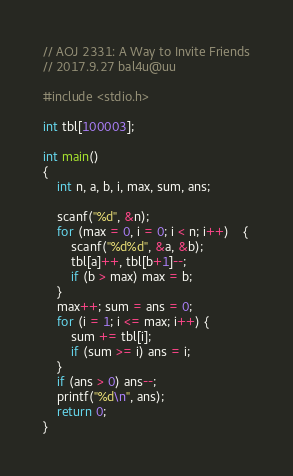Convert code to text. <code><loc_0><loc_0><loc_500><loc_500><_C_>// AOJ 2331: A Way to Invite Friends
// 2017.9.27 bal4u@uu

#include <stdio.h>

int tbl[100003];

int main()
{
	int n, a, b, i, max, sum, ans;

	scanf("%d", &n);
	for (max = 0, i = 0; i < n; i++)	{
		scanf("%d%d", &a, &b);
		tbl[a]++, tbl[b+1]--;
		if (b > max) max = b;
	}
	max++; sum = ans = 0;
	for (i = 1; i <= max; i++) {
		sum += tbl[i];
		if (sum >= i) ans = i;
	}
	if (ans > 0) ans--;
	printf("%d\n", ans);
	return 0;
}</code> 